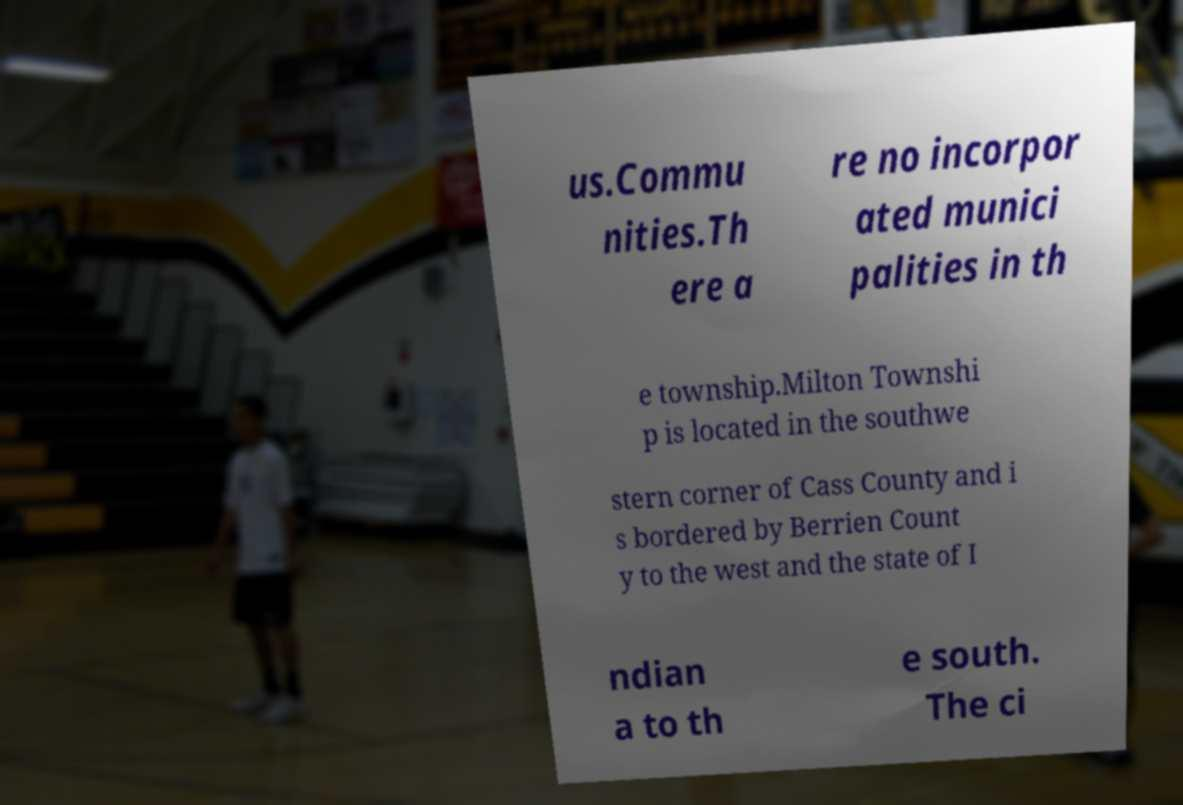Please read and relay the text visible in this image. What does it say? us.Commu nities.Th ere a re no incorpor ated munici palities in th e township.Milton Townshi p is located in the southwe stern corner of Cass County and i s bordered by Berrien Count y to the west and the state of I ndian a to th e south. The ci 